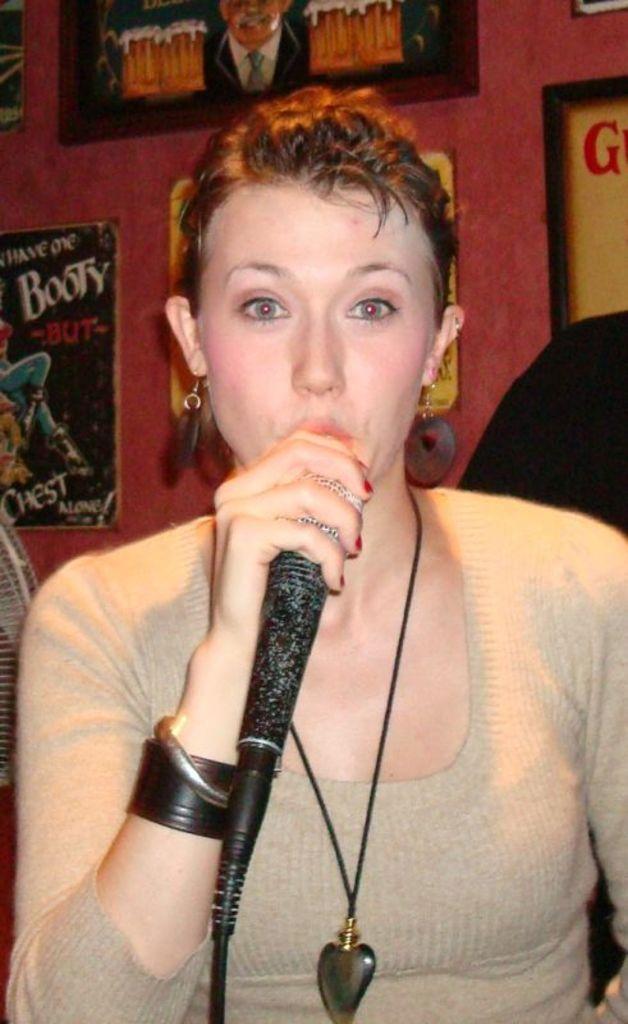Describe this image in one or two sentences. A lady with grey t-shirt is holding a mic in her right hand. At the back of her there are some frames and posters to the wall. 